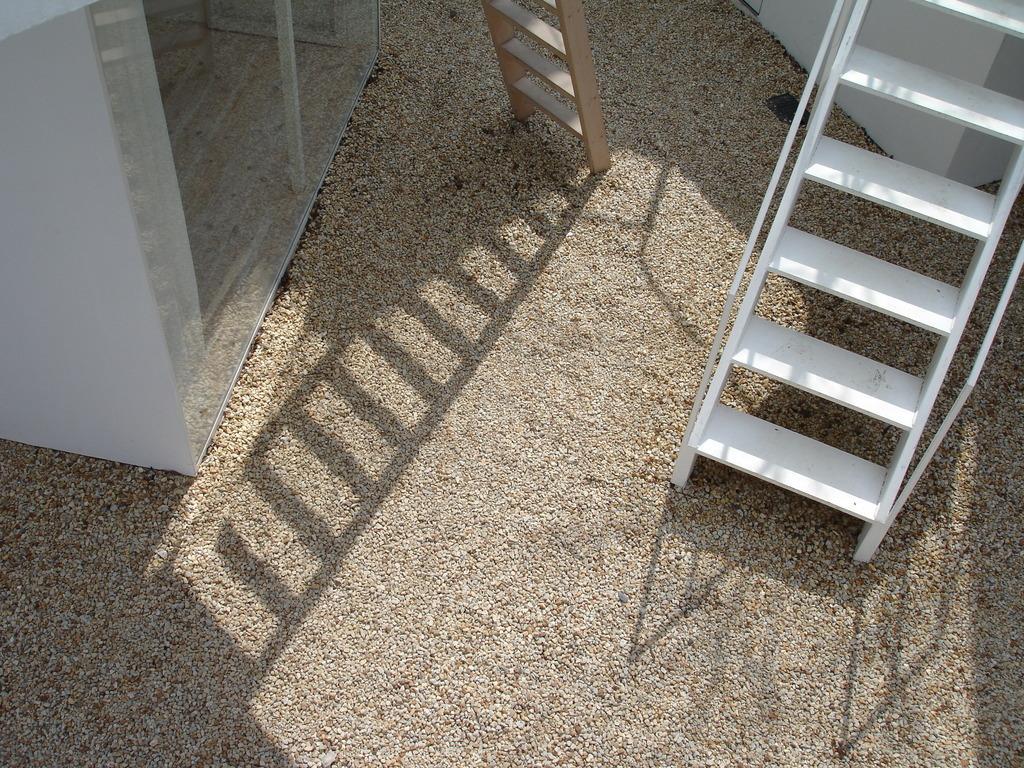Could you give a brief overview of what you see in this image? At the top of the picture there are staircase, ladder and a glass window and wall. At the bottom and center it is sand. 